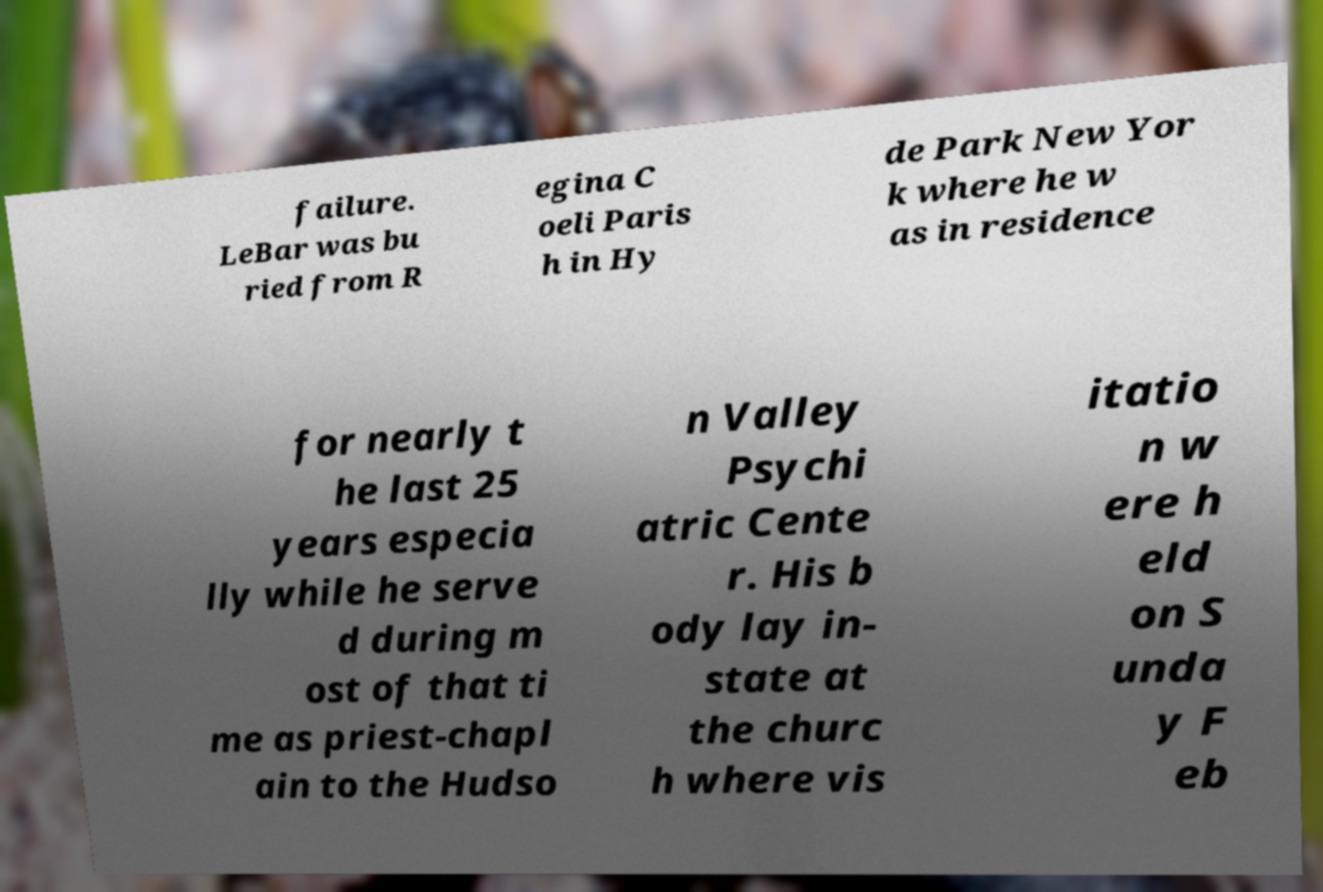There's text embedded in this image that I need extracted. Can you transcribe it verbatim? failure. LeBar was bu ried from R egina C oeli Paris h in Hy de Park New Yor k where he w as in residence for nearly t he last 25 years especia lly while he serve d during m ost of that ti me as priest-chapl ain to the Hudso n Valley Psychi atric Cente r. His b ody lay in- state at the churc h where vis itatio n w ere h eld on S unda y F eb 